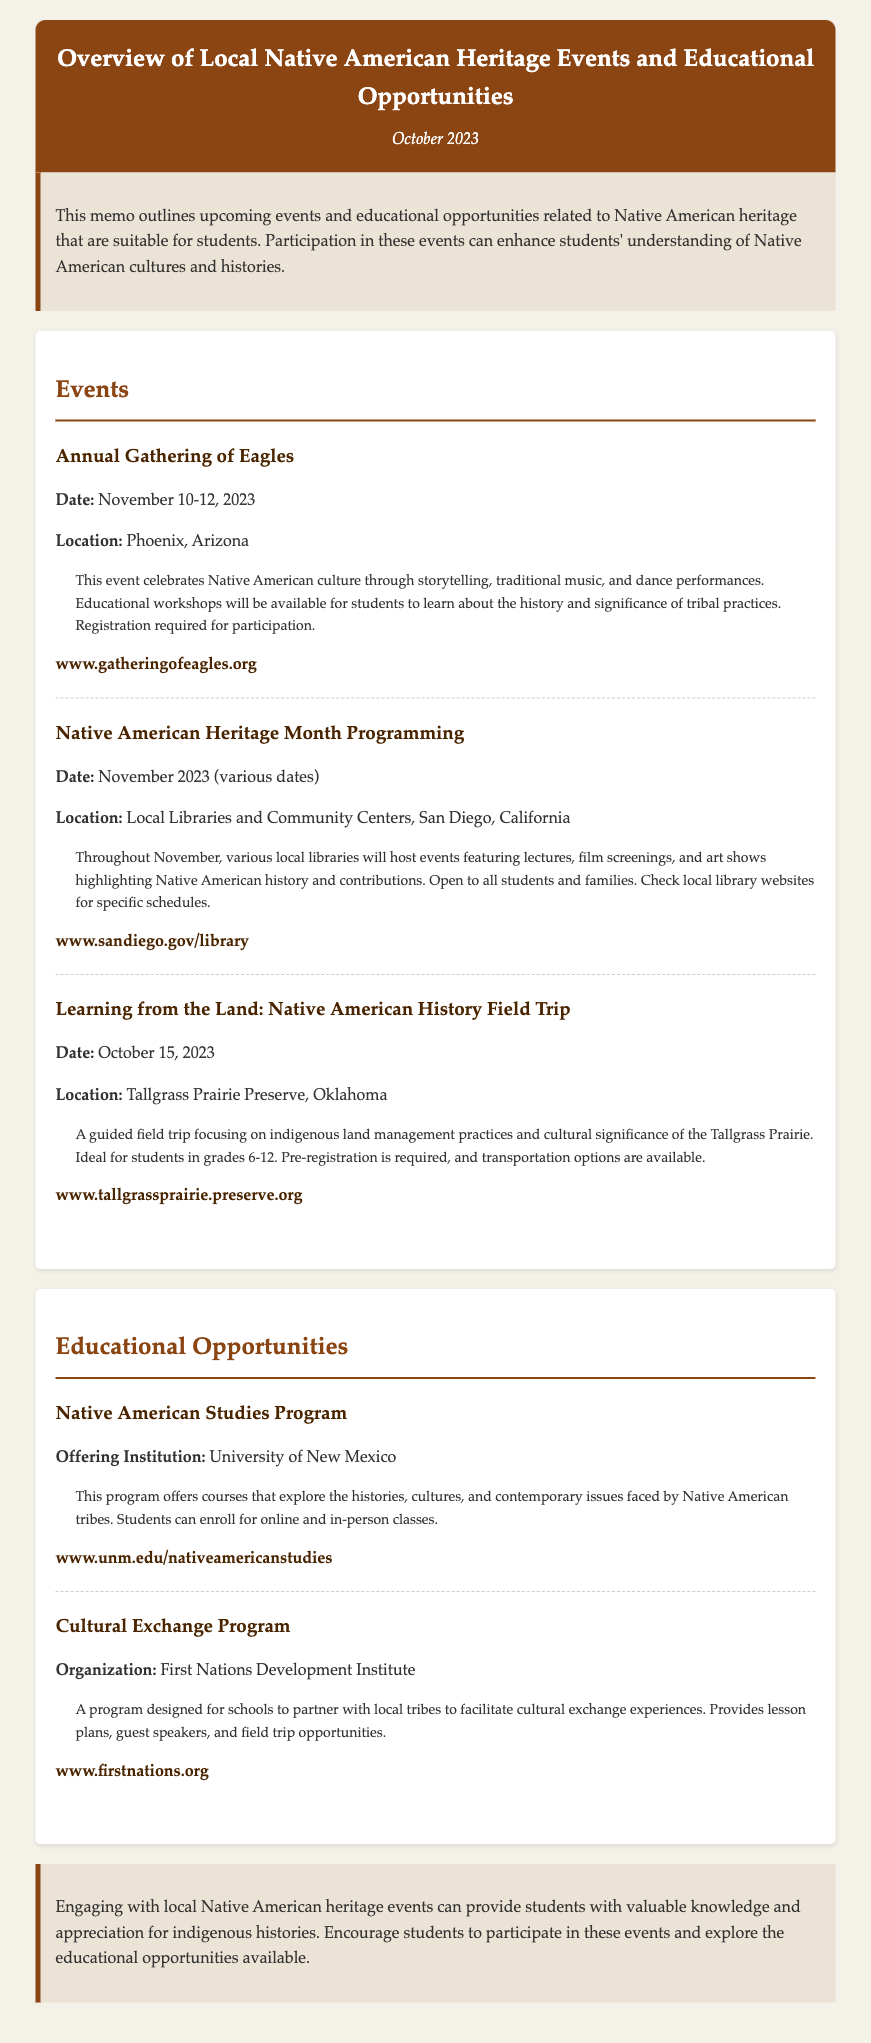What is the date of the Annual Gathering of Eagles? The document states that the Annual Gathering of Eagles is scheduled for November 10-12, 2023.
Answer: November 10-12, 2023 Where will the Learning from the Land field trip take place? According to the document, the Learning from the Land field trip is located at Tallgrass Prairie Preserve, Oklahoma.
Answer: Tallgrass Prairie Preserve, Oklahoma What is one theme of the Native American Heritage Month Programming? The document mentions themes such as lectures, film screenings, and art shows highlighting Native American history and contributions.
Answer: Highlighting Native American history Who is offering the Native American Studies Program? The document identifies the University of New Mexico as the offering institution for the Native American Studies Program.
Answer: University of New Mexico What is required for participation in the Annual Gathering of Eagles? The document states that registration is required for participation in the Annual Gathering of Eagles.
Answer: Registration What types of classes does the Native American Studies Program offer? The document describes that the Native American Studies Program offers online and in-person classes exploring histories, cultures, and contemporary issues.
Answer: Online and in-person classes Which organization runs the Cultural Exchange Program? The document specifies that the First Nations Development Institute organizes the Cultural Exchange Program.
Answer: First Nations Development Institute What is the ideal student grade range for the Learning from the Land field trip? The document indicates that the field trip is ideal for students in grades 6-12.
Answer: Grades 6-12 How can students learn about the specific dates for Native American Heritage Month events? The document suggests checking local library websites for specific schedules of events.
Answer: Check local library websites 